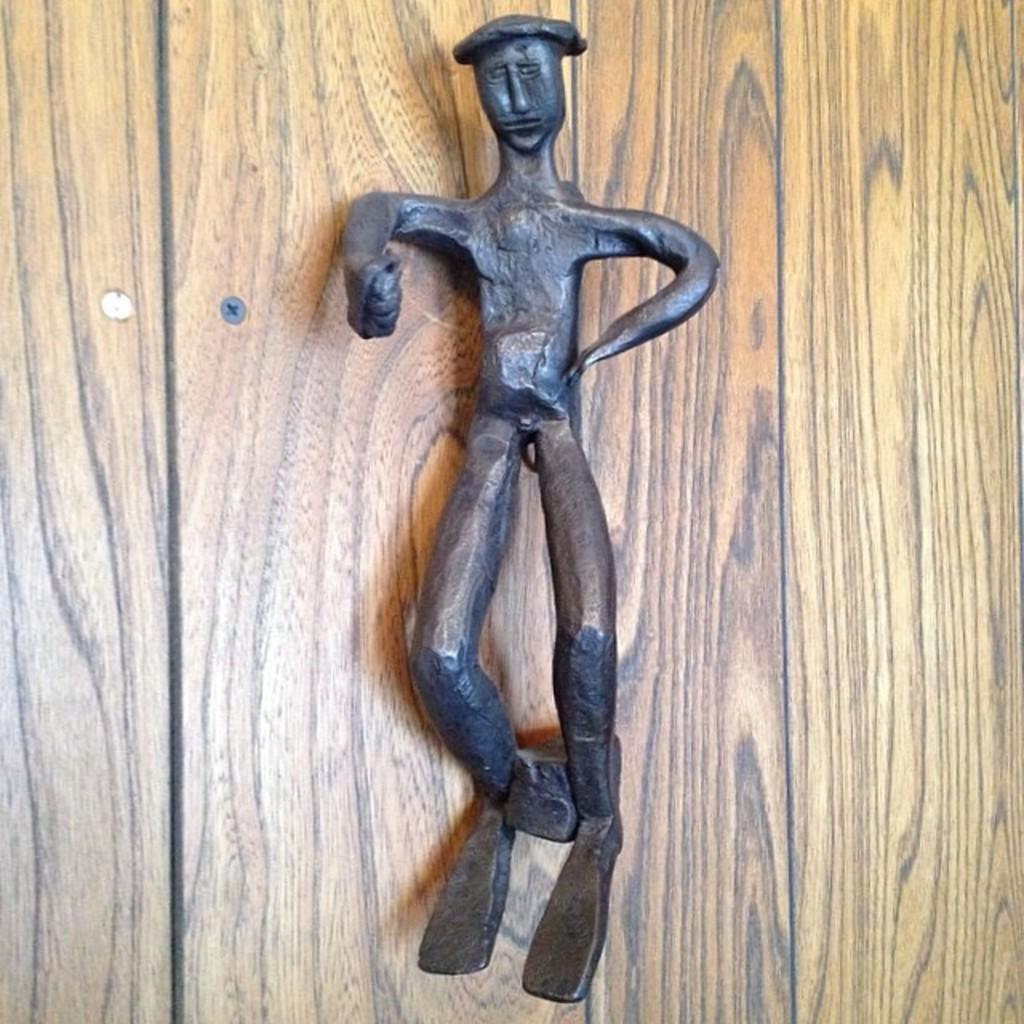What material is the main object in the image made of? The main object in the image is made of iron. Can you describe the object behind the iron object? There is a wooden object behind the iron object. What type of cactus can be seen growing on the island in the image? There is no cactus or island present in the image; it only features an iron object and a wooden object. 